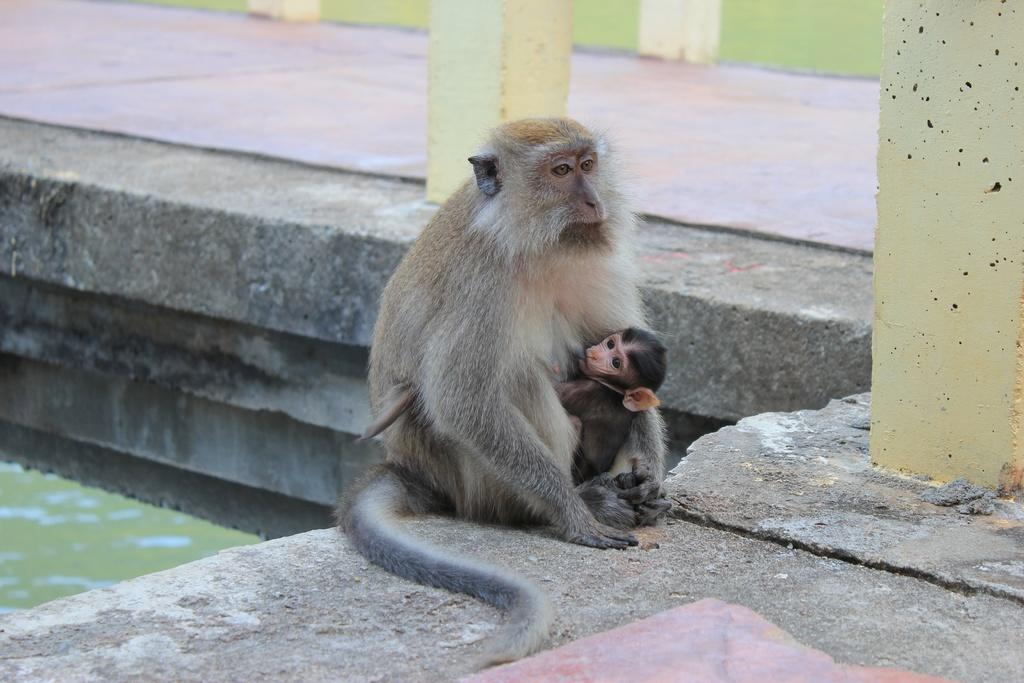What animals are in the center of the image? There are monkeys in the center of the image. What are the monkeys doing in the image? The monkeys are sitting on the floor. What can be seen in the background of the image? There are pillars and a wall in the background of the image. What type of rod is the monkey holding in the image? There is no rod present in the image; the monkeys are sitting on the floor without any objects. 